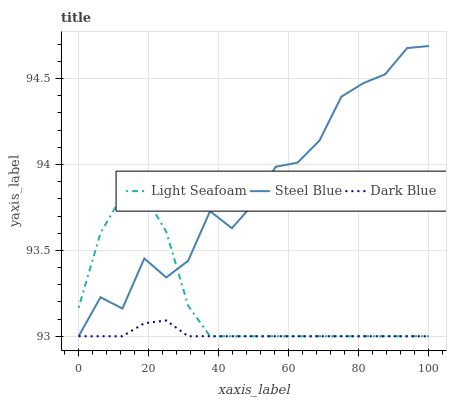Does Dark Blue have the minimum area under the curve?
Answer yes or no. Yes. Does Steel Blue have the maximum area under the curve?
Answer yes or no. Yes. Does Light Seafoam have the minimum area under the curve?
Answer yes or no. No. Does Light Seafoam have the maximum area under the curve?
Answer yes or no. No. Is Dark Blue the smoothest?
Answer yes or no. Yes. Is Steel Blue the roughest?
Answer yes or no. Yes. Is Light Seafoam the smoothest?
Answer yes or no. No. Is Light Seafoam the roughest?
Answer yes or no. No. Does Dark Blue have the lowest value?
Answer yes or no. Yes. Does Steel Blue have the highest value?
Answer yes or no. Yes. Does Light Seafoam have the highest value?
Answer yes or no. No. Does Dark Blue intersect Light Seafoam?
Answer yes or no. Yes. Is Dark Blue less than Light Seafoam?
Answer yes or no. No. Is Dark Blue greater than Light Seafoam?
Answer yes or no. No. 